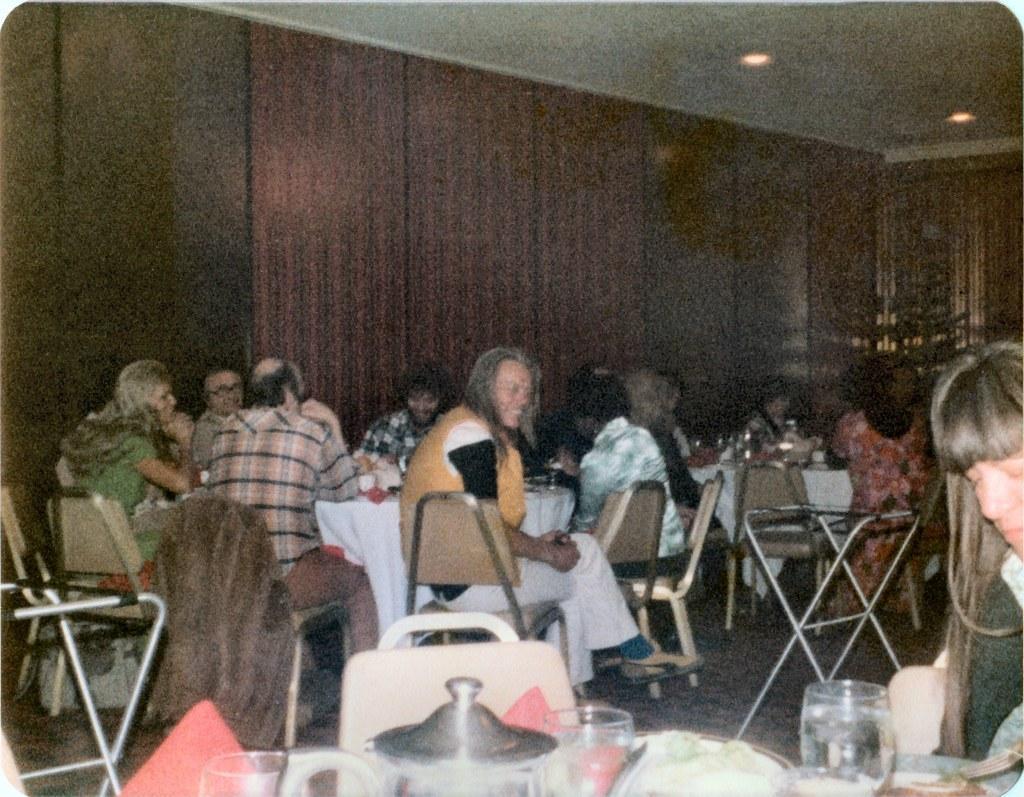In one or two sentences, can you explain what this image depicts? This is a photo. In this picture we can see the wall, plant, tables and some people are sitting on the chairs. On the tables we can see the vessels, glass, papers, plates which contain food items. In the background of the image we can see the floor. At the top of the image we can see the roof and lights. 